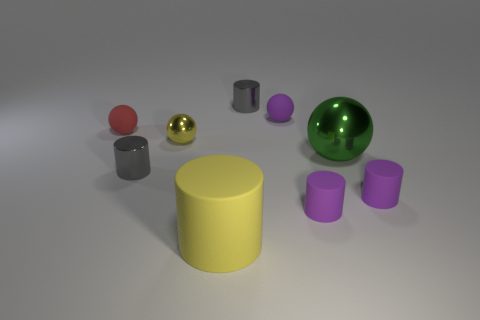How does the lighting in the scene affect the appearance of the objects? The lighting casts soft shadows to the right of the objects, indicating a light source to the left of the frame. It brings out the textures and colors of the objects, highlighting their material attributes—like the shine on the metallic surfaces and the transparency of the green glass-like sphere. 